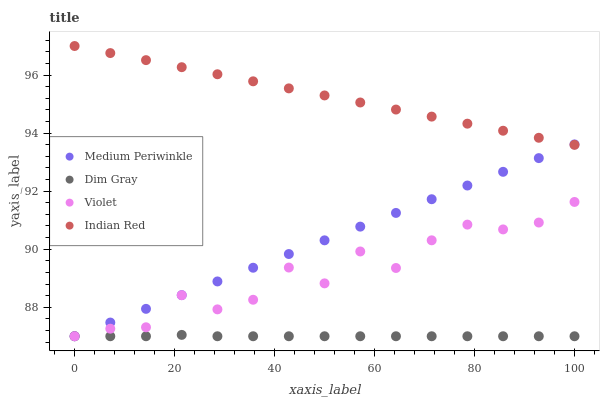Does Dim Gray have the minimum area under the curve?
Answer yes or no. Yes. Does Indian Red have the maximum area under the curve?
Answer yes or no. Yes. Does Medium Periwinkle have the minimum area under the curve?
Answer yes or no. No. Does Medium Periwinkle have the maximum area under the curve?
Answer yes or no. No. Is Medium Periwinkle the smoothest?
Answer yes or no. Yes. Is Violet the roughest?
Answer yes or no. Yes. Is Indian Red the smoothest?
Answer yes or no. No. Is Indian Red the roughest?
Answer yes or no. No. Does Dim Gray have the lowest value?
Answer yes or no. Yes. Does Indian Red have the lowest value?
Answer yes or no. No. Does Indian Red have the highest value?
Answer yes or no. Yes. Does Medium Periwinkle have the highest value?
Answer yes or no. No. Is Violet less than Indian Red?
Answer yes or no. Yes. Is Indian Red greater than Dim Gray?
Answer yes or no. Yes. Does Medium Periwinkle intersect Indian Red?
Answer yes or no. Yes. Is Medium Periwinkle less than Indian Red?
Answer yes or no. No. Is Medium Periwinkle greater than Indian Red?
Answer yes or no. No. Does Violet intersect Indian Red?
Answer yes or no. No. 